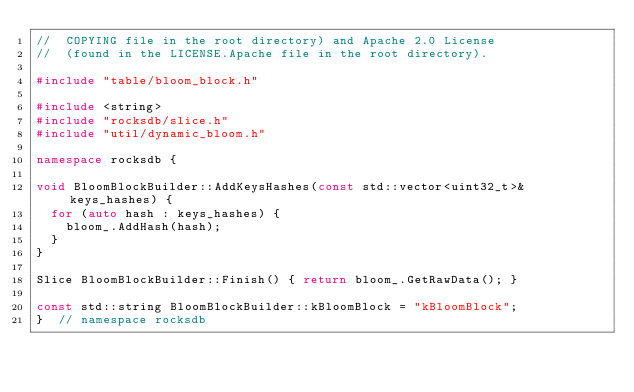Convert code to text. <code><loc_0><loc_0><loc_500><loc_500><_C++_>//  COPYING file in the root directory) and Apache 2.0 License
//  (found in the LICENSE.Apache file in the root directory).

#include "table/bloom_block.h"

#include <string>
#include "rocksdb/slice.h"
#include "util/dynamic_bloom.h"

namespace rocksdb {

void BloomBlockBuilder::AddKeysHashes(const std::vector<uint32_t>& keys_hashes) {
  for (auto hash : keys_hashes) {
    bloom_.AddHash(hash);
  }
}

Slice BloomBlockBuilder::Finish() { return bloom_.GetRawData(); }

const std::string BloomBlockBuilder::kBloomBlock = "kBloomBlock";
}  // namespace rocksdb
</code> 